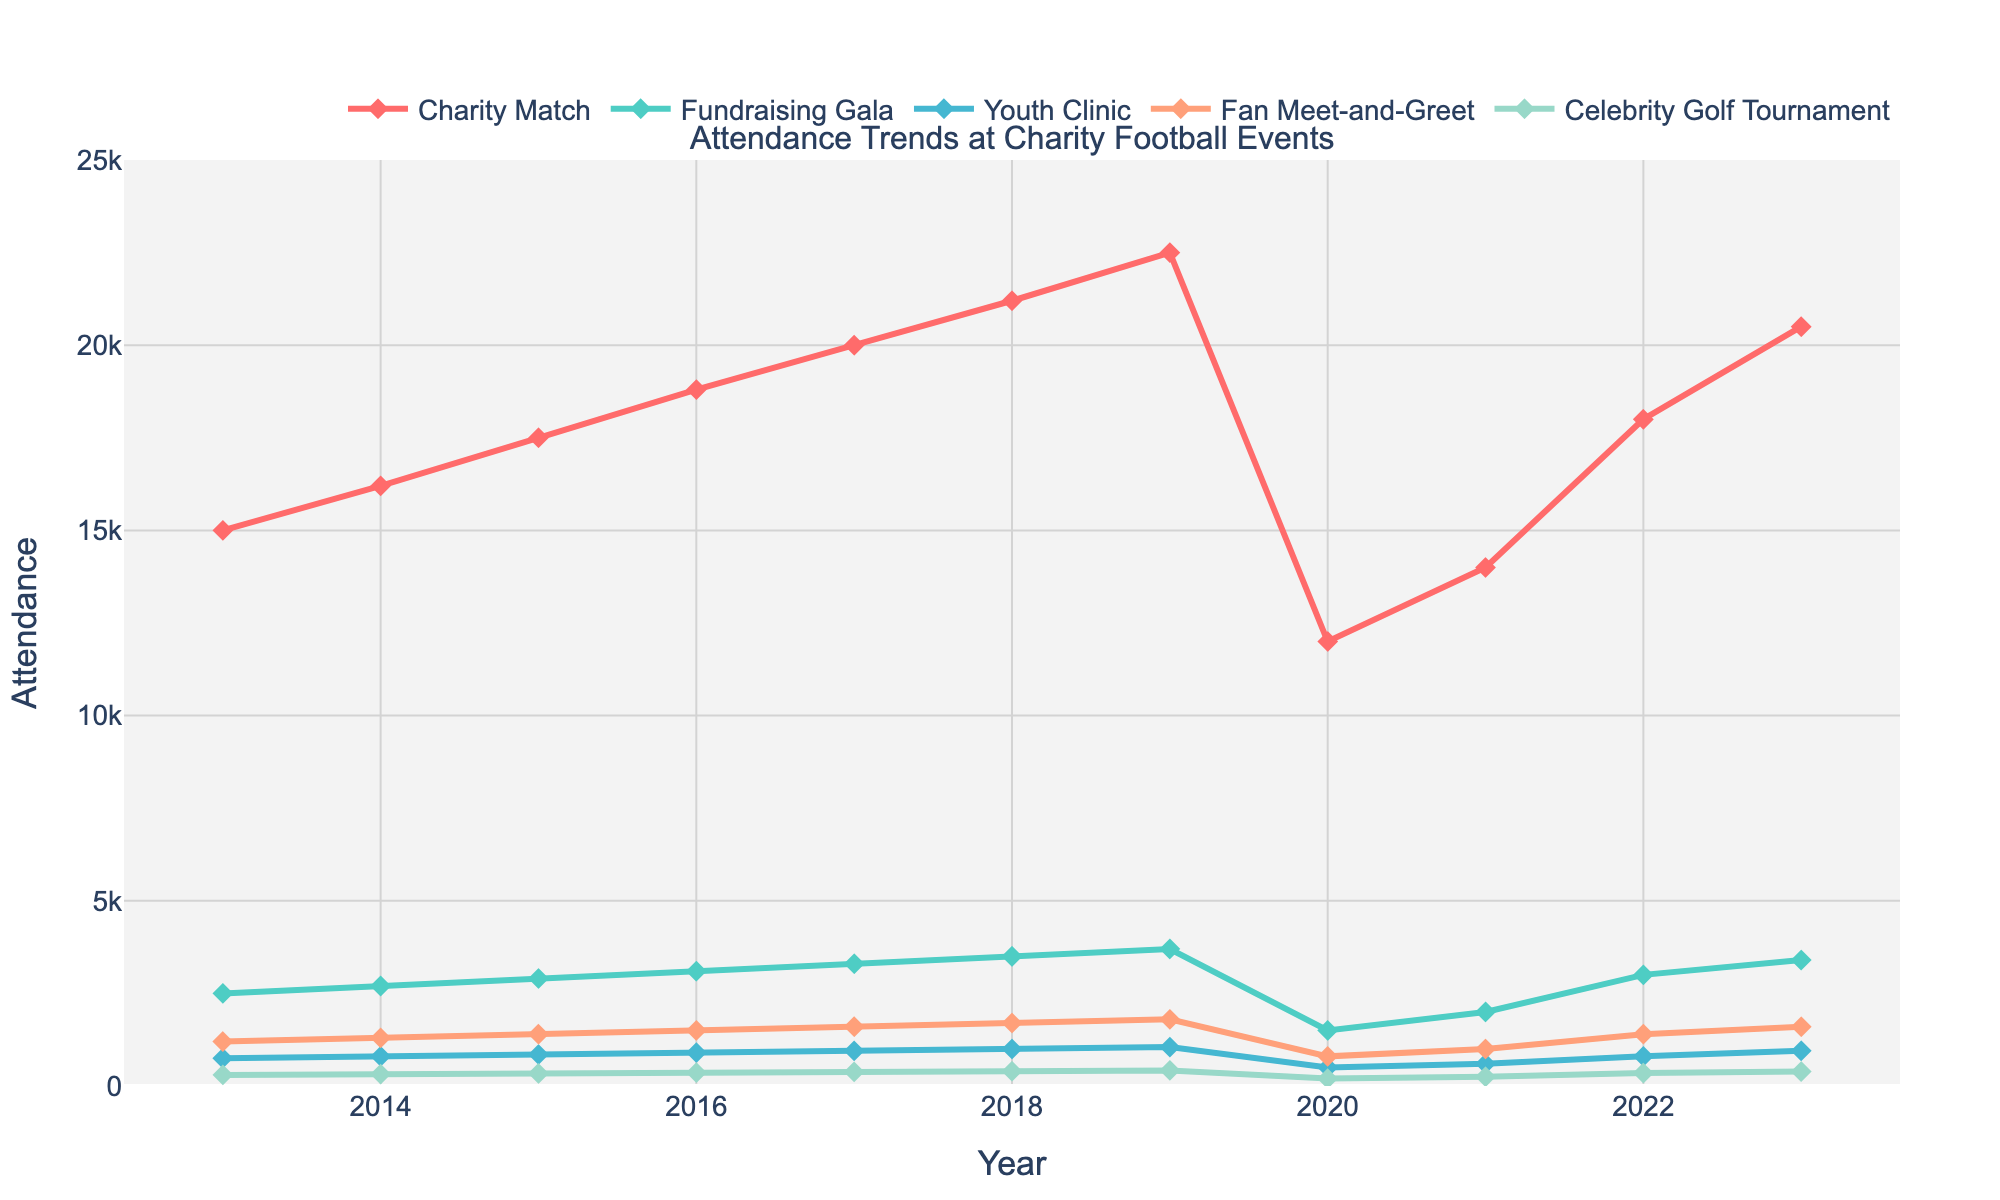Which event had the highest attendance in 2023? By looking at the lines on the chart for the year 2023, identify the event line that reaches the highest value. The "Charity Match" line is the highest at around 20500.
Answer: Charity Match Which event had the lowest attendance in 2020? Check the lines on the chart for the year 2020 and identify the line that is at the lowest point. The "Celebrity Golf Tournament" line is the lowest at around 200.
Answer: Celebrity Golf Tournament How did the attendance at Charities Matches change from 2017 to 2018? Look at the "Charity Match" line between 2017 and 2018 and note the change in height. The attendance increased from around 20000 to 21200, which is an increase of 1200.
Answer: Increased by 1200 Which event type saw a drop in attendance in 2020 compared to 2019? Compare the heights of all event lines for 2020 and 2019 and identify which lines are higher in 2019 than in 2020. All events saw a drop, with "Charity Match" dropping from 22500 to 12000, "Fundraising Gala" from 3700 to 1500, etc.
Answer: All events Compare the attendance trend of "Youth Clinic" to "Fan Meet-and-Greet" over the years. Observe the lines representing "Youth Clinic" and "Fan Meet-and-Greet" from 2013 to 2023. Both show an overall increasing trend, but "Youth Clinic" has smaller attendance values, and the changes are less steep. Both lines have a dip in 2020, followed by a recovery.
Answer: Both increased similarly Calculate the average attendance for Fundraising Gala events from 2013 to 2023. Sum the attendance values for Fundraising Gala (2500, 2700, 2900, 3100, 3300, 3500, 3700, 1500, 2000, 3000, 3400) and divide by the number of years (11). The sum is 31500, so 31500 / 11 equals approximately 2864.
Answer: 2864 By how much did the attendance for "Celebrity Golf Tournament" increase from 2013 to 2023? Subtract the 2013 value of attendance (300) for "Celebrity Golf Tournament" from the 2023 value (390). The difference is 390 - 300, which is 90.
Answer: 90 